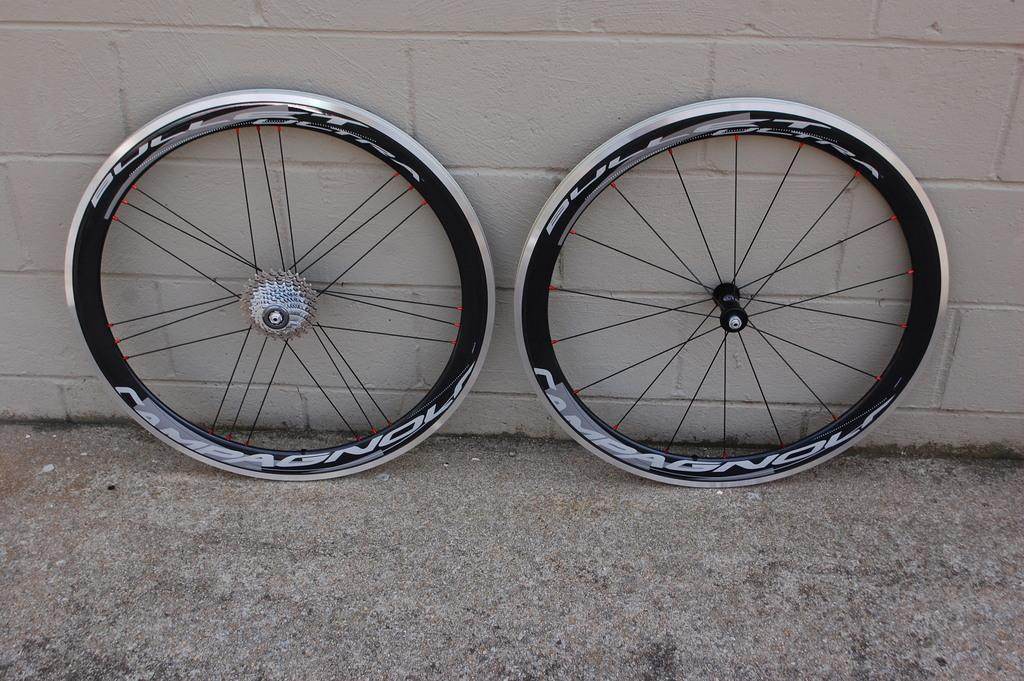What is located in the center of the image? There are two wheels in the center of the image. What can be seen in the background of the image? There is a wall in the background of the image. What is at the bottom of the image? There is a walkway at the bottom of the image. How many rabbits can be seen hopping on the walkway in the image? There are no rabbits present in the image; it only features two wheels and a wall in the background. 